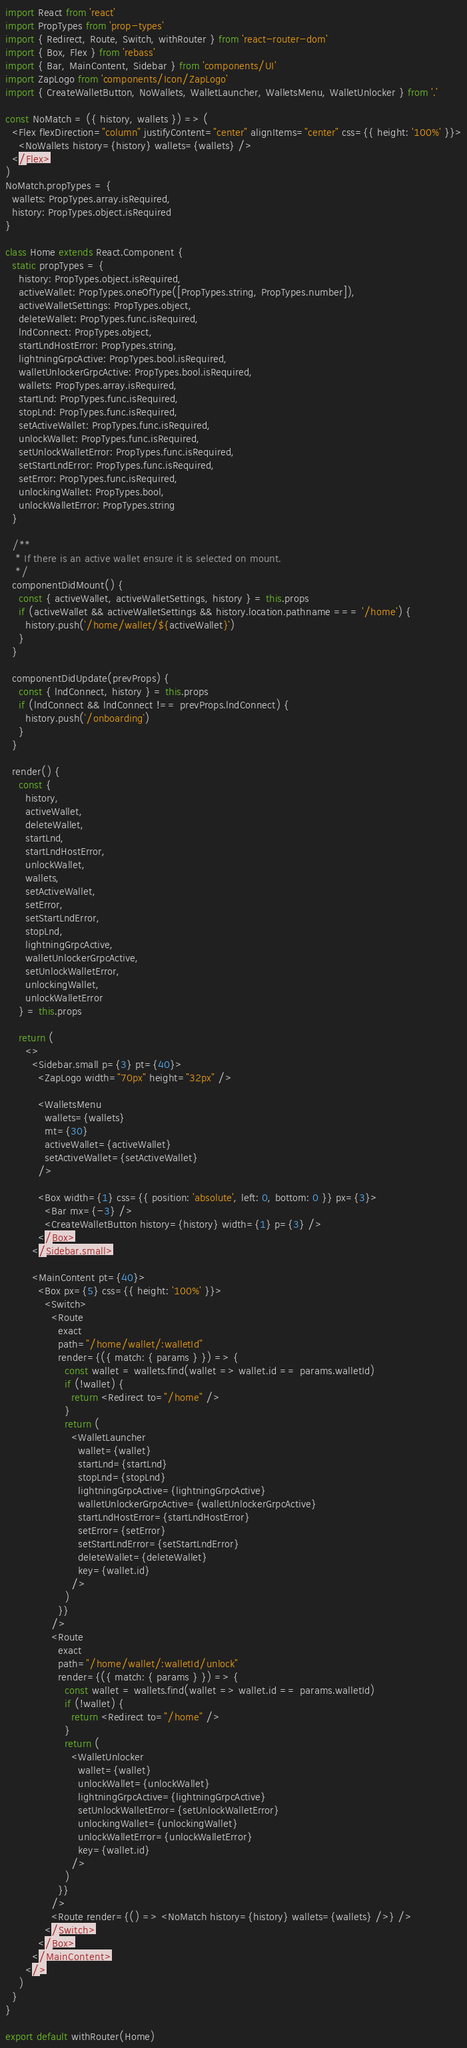<code> <loc_0><loc_0><loc_500><loc_500><_JavaScript_>import React from 'react'
import PropTypes from 'prop-types'
import { Redirect, Route, Switch, withRouter } from 'react-router-dom'
import { Box, Flex } from 'rebass'
import { Bar, MainContent, Sidebar } from 'components/UI'
import ZapLogo from 'components/Icon/ZapLogo'
import { CreateWalletButton, NoWallets, WalletLauncher, WalletsMenu, WalletUnlocker } from '.'

const NoMatch = ({ history, wallets }) => (
  <Flex flexDirection="column" justifyContent="center" alignItems="center" css={{ height: '100%' }}>
    <NoWallets history={history} wallets={wallets} />
  </Flex>
)
NoMatch.propTypes = {
  wallets: PropTypes.array.isRequired,
  history: PropTypes.object.isRequired
}

class Home extends React.Component {
  static propTypes = {
    history: PropTypes.object.isRequired,
    activeWallet: PropTypes.oneOfType([PropTypes.string, PropTypes.number]),
    activeWalletSettings: PropTypes.object,
    deleteWallet: PropTypes.func.isRequired,
    lndConnect: PropTypes.object,
    startLndHostError: PropTypes.string,
    lightningGrpcActive: PropTypes.bool.isRequired,
    walletUnlockerGrpcActive: PropTypes.bool.isRequired,
    wallets: PropTypes.array.isRequired,
    startLnd: PropTypes.func.isRequired,
    stopLnd: PropTypes.func.isRequired,
    setActiveWallet: PropTypes.func.isRequired,
    unlockWallet: PropTypes.func.isRequired,
    setUnlockWalletError: PropTypes.func.isRequired,
    setStartLndError: PropTypes.func.isRequired,
    setError: PropTypes.func.isRequired,
    unlockingWallet: PropTypes.bool,
    unlockWalletError: PropTypes.string
  }

  /**
   * If there is an active wallet ensure it is selected on mount.
   */
  componentDidMount() {
    const { activeWallet, activeWalletSettings, history } = this.props
    if (activeWallet && activeWalletSettings && history.location.pathname === '/home') {
      history.push(`/home/wallet/${activeWallet}`)
    }
  }

  componentDidUpdate(prevProps) {
    const { lndConnect, history } = this.props
    if (lndConnect && lndConnect !== prevProps.lndConnect) {
      history.push(`/onboarding`)
    }
  }

  render() {
    const {
      history,
      activeWallet,
      deleteWallet,
      startLnd,
      startLndHostError,
      unlockWallet,
      wallets,
      setActiveWallet,
      setError,
      setStartLndError,
      stopLnd,
      lightningGrpcActive,
      walletUnlockerGrpcActive,
      setUnlockWalletError,
      unlockingWallet,
      unlockWalletError
    } = this.props

    return (
      <>
        <Sidebar.small p={3} pt={40}>
          <ZapLogo width="70px" height="32px" />

          <WalletsMenu
            wallets={wallets}
            mt={30}
            activeWallet={activeWallet}
            setActiveWallet={setActiveWallet}
          />

          <Box width={1} css={{ position: 'absolute', left: 0, bottom: 0 }} px={3}>
            <Bar mx={-3} />
            <CreateWalletButton history={history} width={1} p={3} />
          </Box>
        </Sidebar.small>

        <MainContent pt={40}>
          <Box px={5} css={{ height: '100%' }}>
            <Switch>
              <Route
                exact
                path="/home/wallet/:walletId"
                render={({ match: { params } }) => {
                  const wallet = wallets.find(wallet => wallet.id == params.walletId)
                  if (!wallet) {
                    return <Redirect to="/home" />
                  }
                  return (
                    <WalletLauncher
                      wallet={wallet}
                      startLnd={startLnd}
                      stopLnd={stopLnd}
                      lightningGrpcActive={lightningGrpcActive}
                      walletUnlockerGrpcActive={walletUnlockerGrpcActive}
                      startLndHostError={startLndHostError}
                      setError={setError}
                      setStartLndError={setStartLndError}
                      deleteWallet={deleteWallet}
                      key={wallet.id}
                    />
                  )
                }}
              />
              <Route
                exact
                path="/home/wallet/:walletId/unlock"
                render={({ match: { params } }) => {
                  const wallet = wallets.find(wallet => wallet.id == params.walletId)
                  if (!wallet) {
                    return <Redirect to="/home" />
                  }
                  return (
                    <WalletUnlocker
                      wallet={wallet}
                      unlockWallet={unlockWallet}
                      lightningGrpcActive={lightningGrpcActive}
                      setUnlockWalletError={setUnlockWalletError}
                      unlockingWallet={unlockingWallet}
                      unlockWalletError={unlockWalletError}
                      key={wallet.id}
                    />
                  )
                }}
              />
              <Route render={() => <NoMatch history={history} wallets={wallets} />} />
            </Switch>
          </Box>
        </MainContent>
      </>
    )
  }
}

export default withRouter(Home)
</code> 